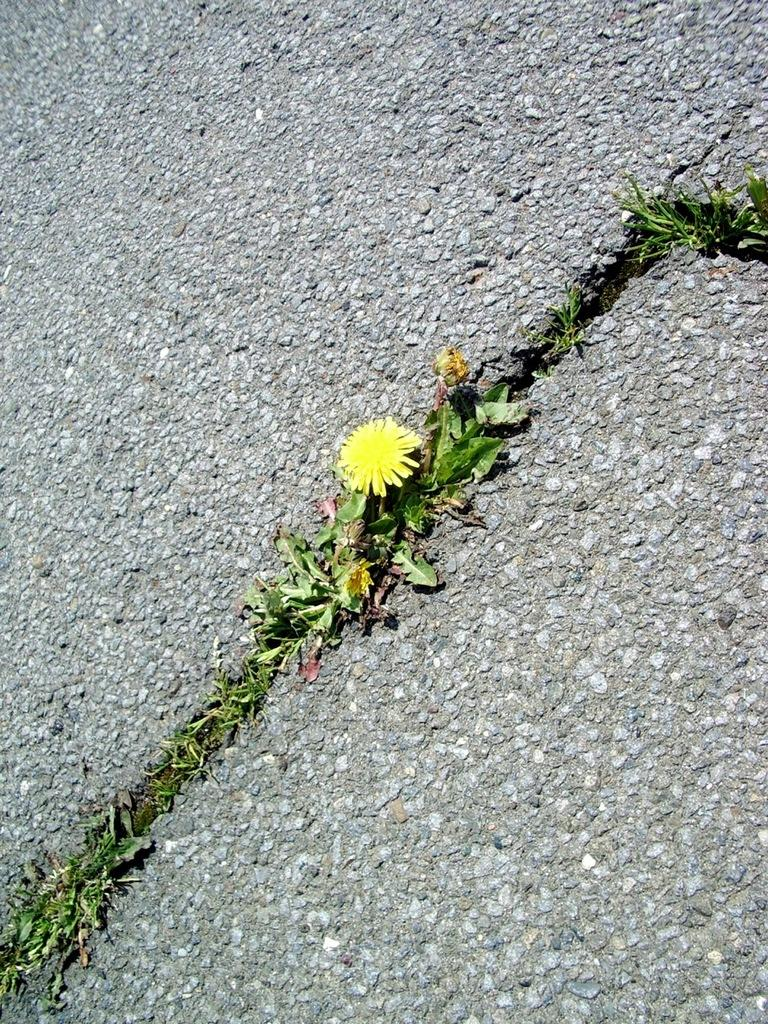What is the main subject of the image? There is a flower in the center of the image. What color is the flower? The flower is yellow. Are there any other parts of the plant visible in the image? Yes, there are leaves associated with the flower. What can be seen in the background of the image? There is a road in the background of the image. How much does the receipt for the flower cost in the image? There is no receipt present in the image, as it is a photograph of a flower and leaves. Is there any steam coming from the flower in the image? No, there is no steam present in the image; it is a still photograph of a flower and leaves. 